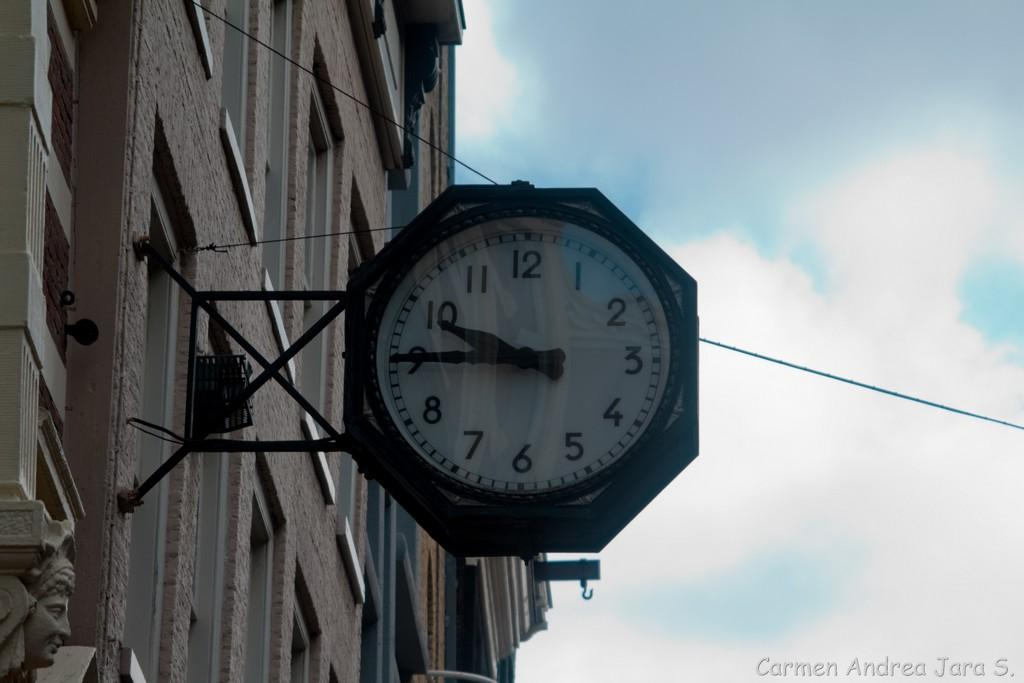<image>
Give a short and clear explanation of the subsequent image. A clock hanging from a building is showing the time 9:45. 